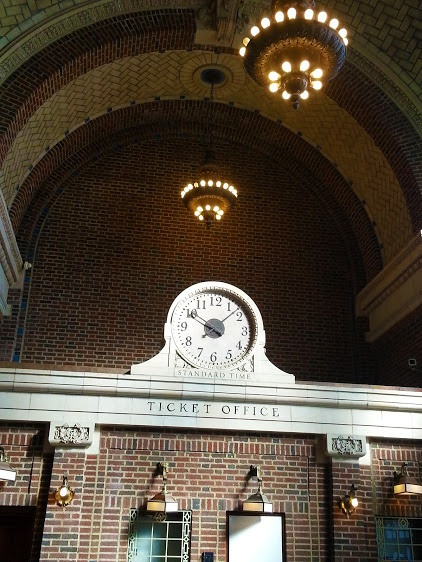Describe the objects in this image and their specific colors. I can see a clock in darkgreen, white, gray, darkgray, and black tones in this image. 